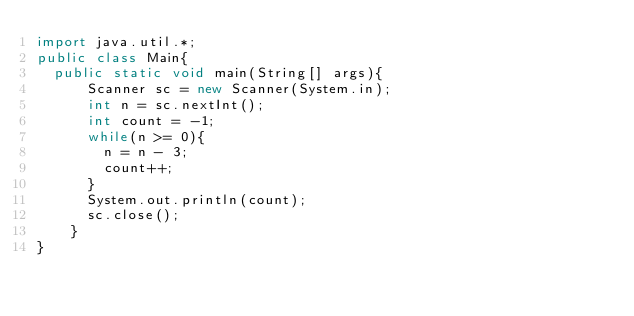<code> <loc_0><loc_0><loc_500><loc_500><_Java_>import java.util.*;
public class Main{
	public static void main(String[] args){
    	Scanner sc = new Scanner(System.in);
      int n = sc.nextInt();
      int count = -1;
      while(n >= 0){
      	n = n - 3;
        count++;
      }
      System.out.println(count);
      sc.close();
    }
}
</code> 